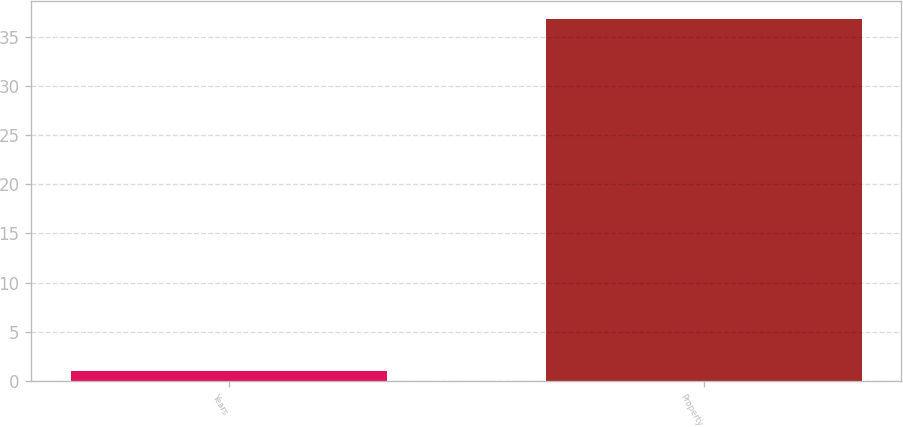<chart> <loc_0><loc_0><loc_500><loc_500><bar_chart><fcel>Years<fcel>Property<nl><fcel>1<fcel>36.8<nl></chart> 